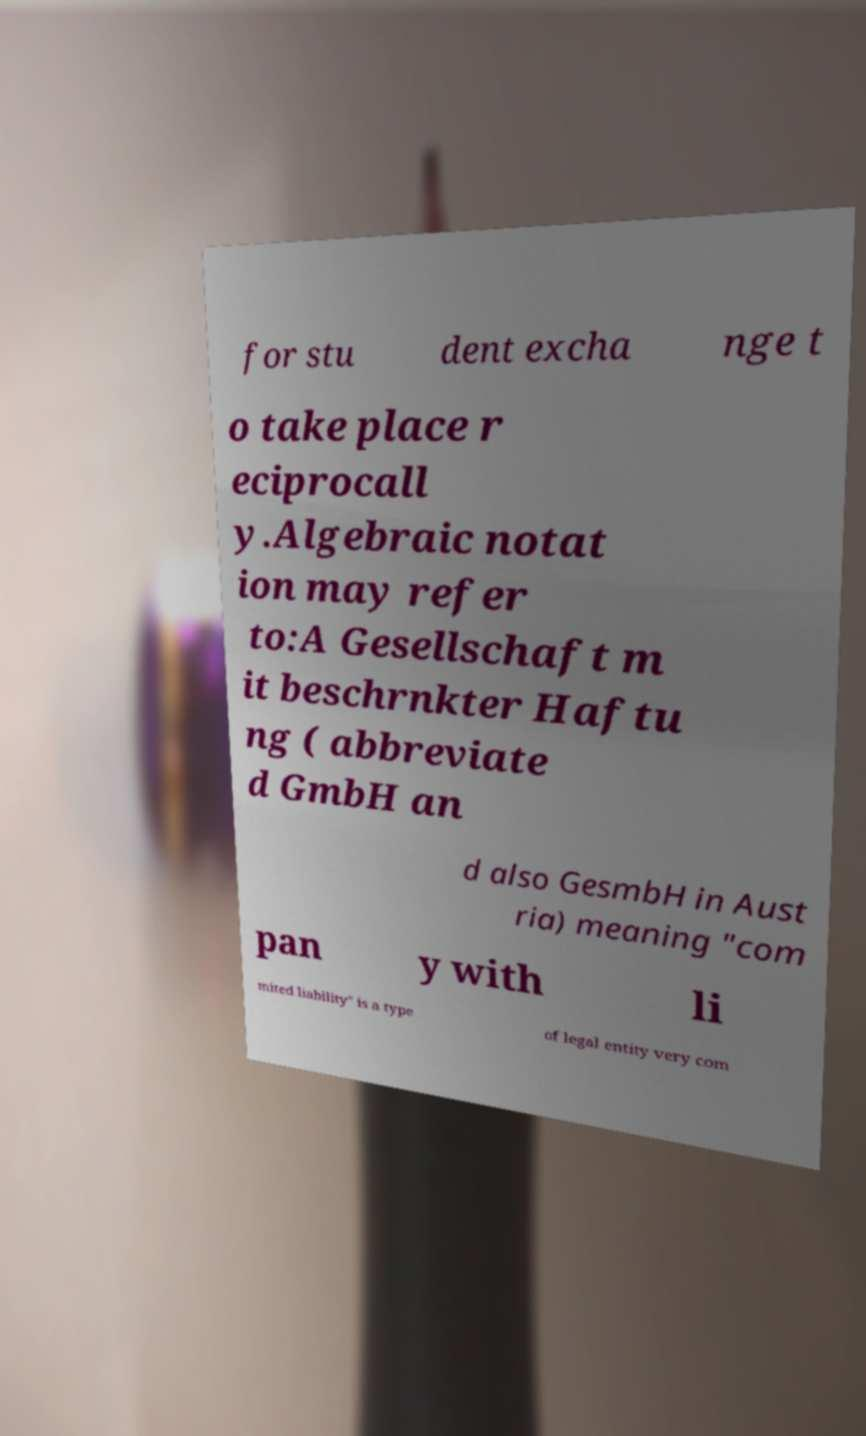Can you read and provide the text displayed in the image?This photo seems to have some interesting text. Can you extract and type it out for me? for stu dent excha nge t o take place r eciprocall y.Algebraic notat ion may refer to:A Gesellschaft m it beschrnkter Haftu ng ( abbreviate d GmbH an d also GesmbH in Aust ria) meaning "com pan y with li mited liability" is a type of legal entity very com 